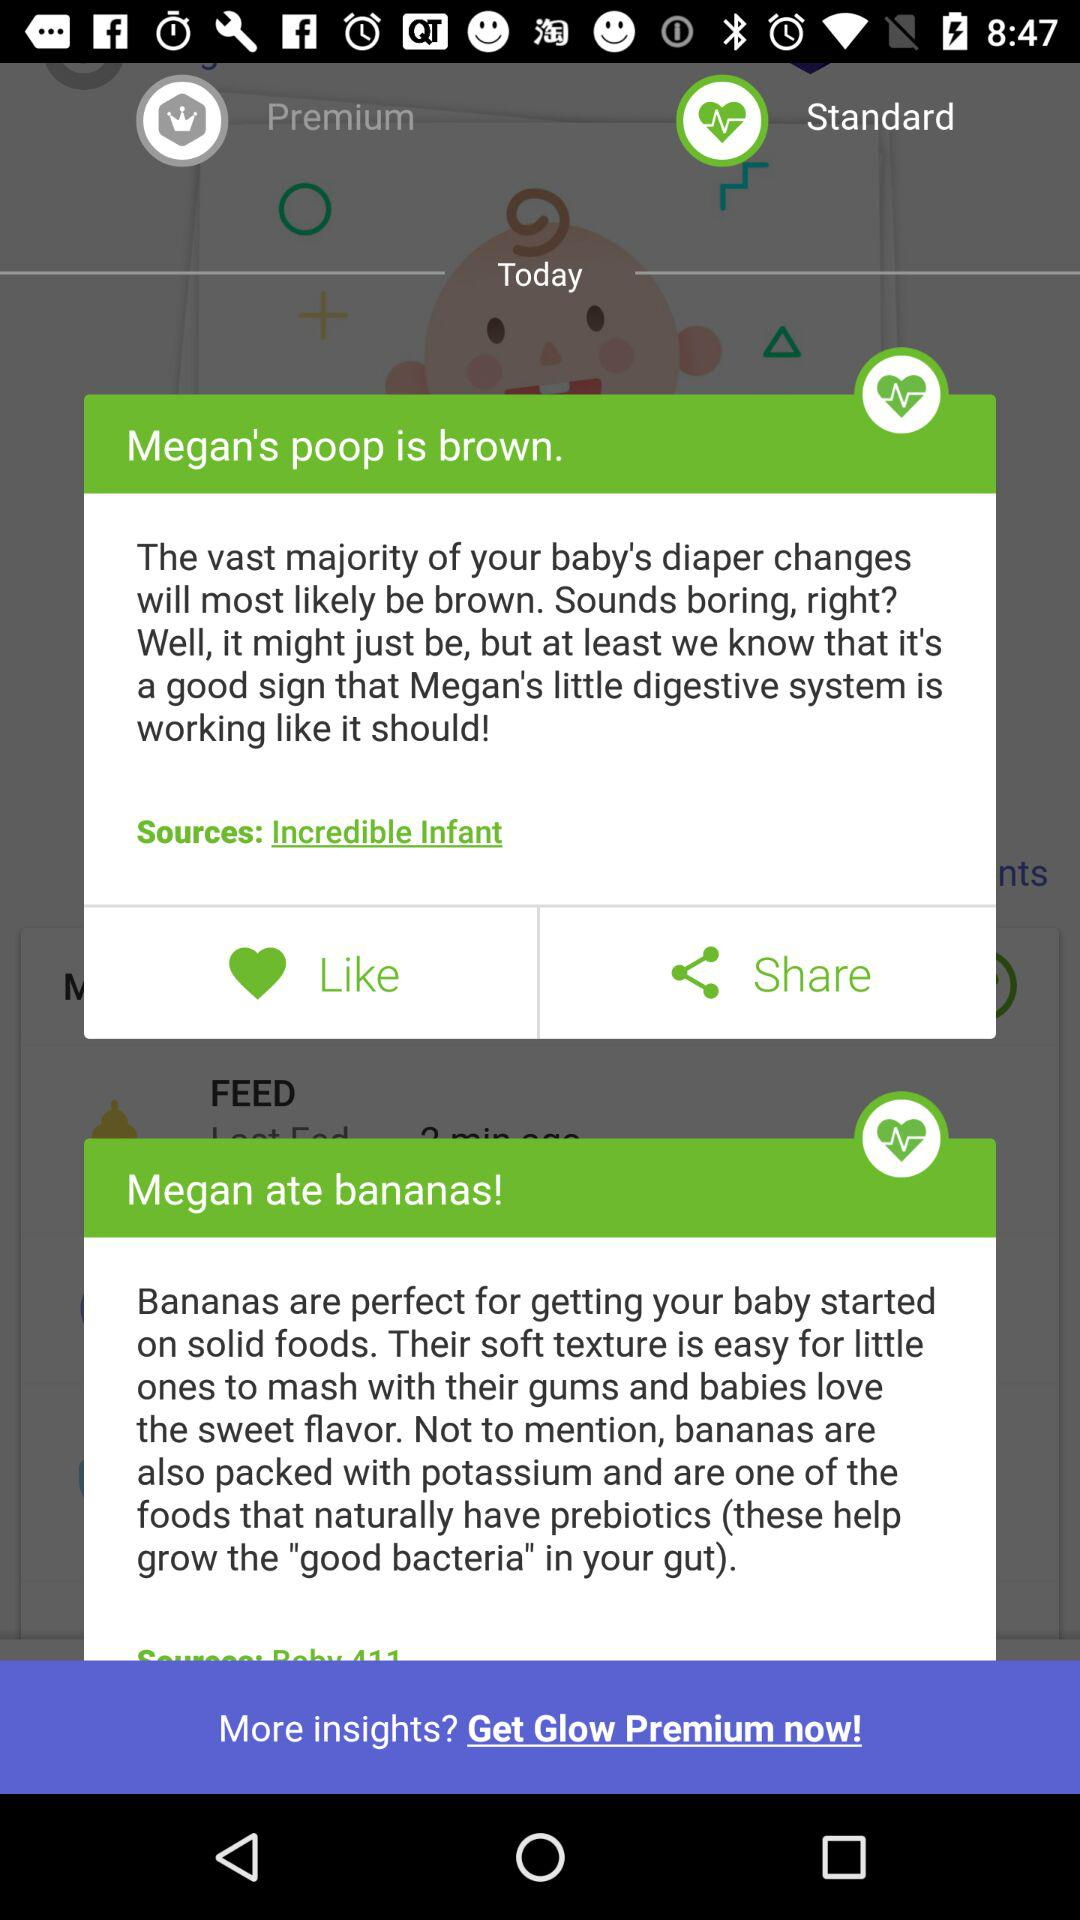What is the baby name? The baby name is Megan. 